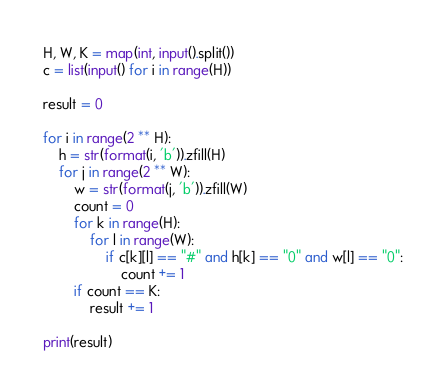<code> <loc_0><loc_0><loc_500><loc_500><_Python_>H, W, K = map(int, input().split())
c = list(input() for i in range(H))

result = 0

for i in range(2 ** H):
    h = str(format(i, 'b')).zfill(H)
    for j in range(2 ** W):
        w = str(format(j, 'b')).zfill(W)
        count = 0
        for k in range(H):
            for l in range(W):
                if c[k][l] == "#" and h[k] == "0" and w[l] == "0":
                    count += 1
        if count == K:
            result += 1

print(result)</code> 